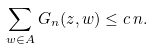Convert formula to latex. <formula><loc_0><loc_0><loc_500><loc_500>\sum _ { w \in A } G _ { n } ( z , w ) \leq c \, n .</formula> 